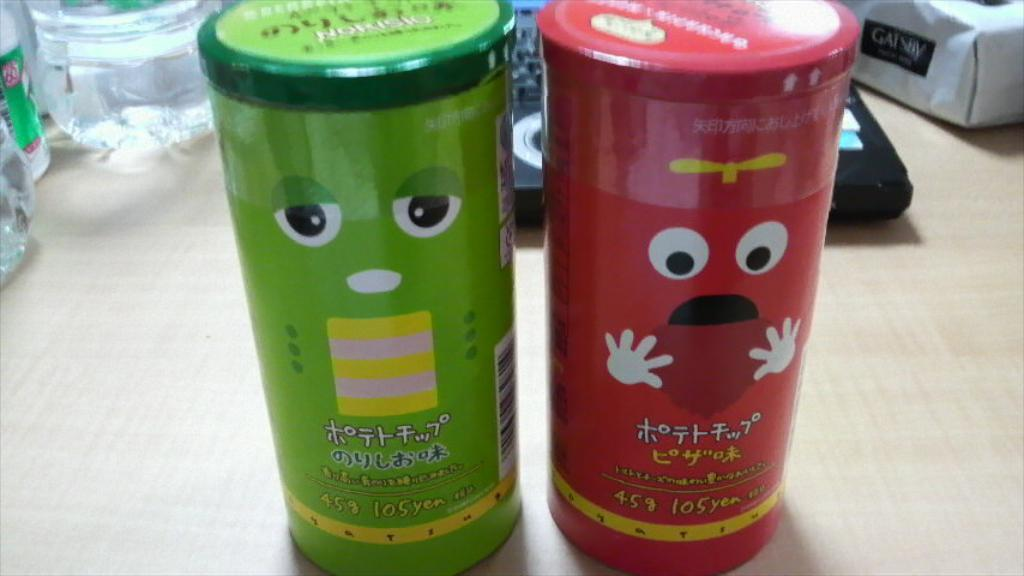How many bottles are visible in the image? There are two bottles in the image. What is on the bottles in the image? The bottles have paint on them. What word is written on the bottles in the image? There is no word written on the bottles in the image; they only have paint on them. 